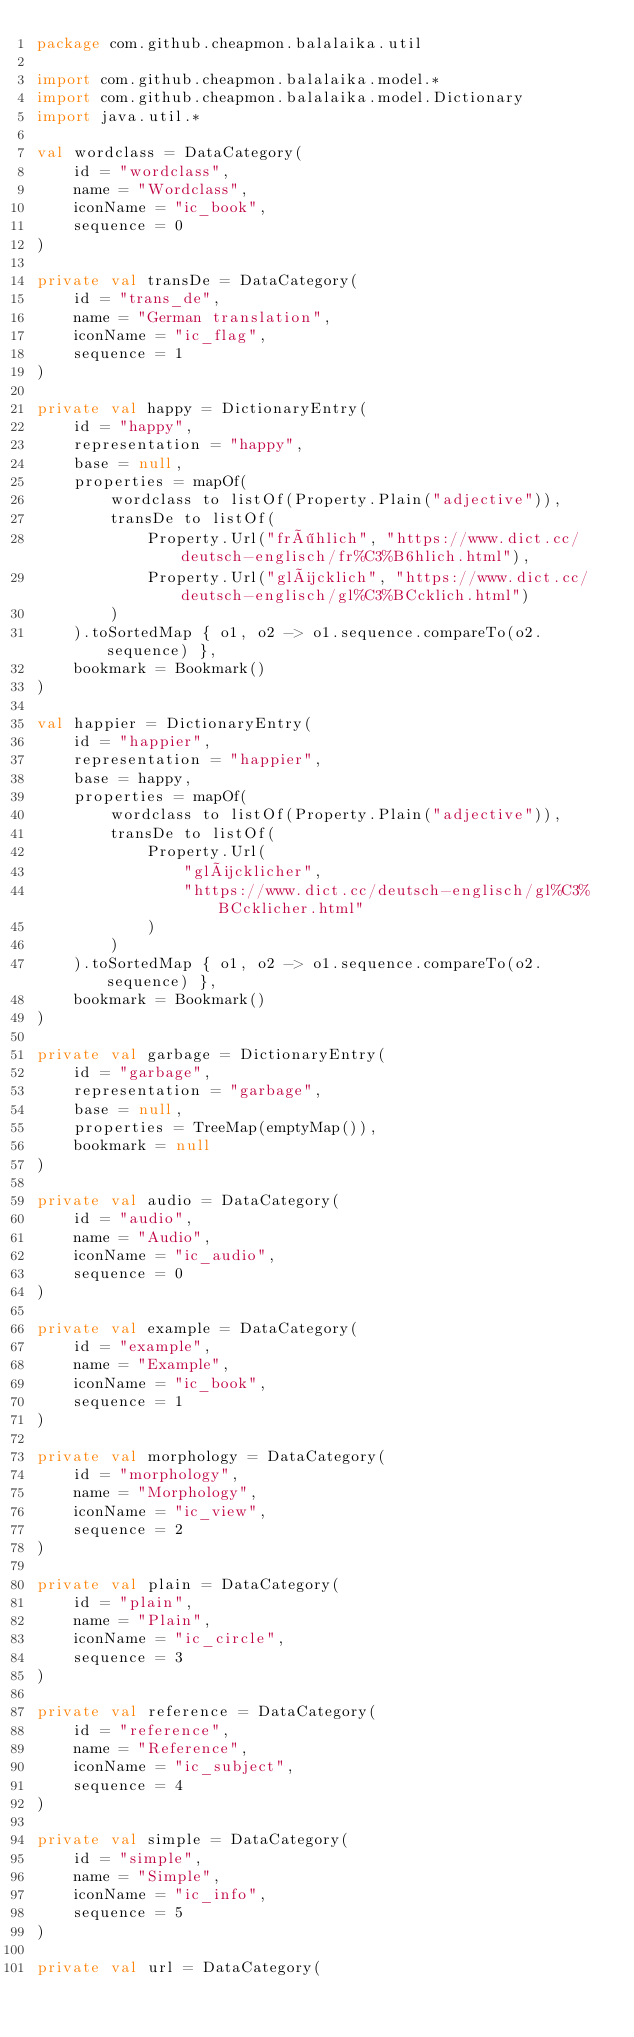<code> <loc_0><loc_0><loc_500><loc_500><_Kotlin_>package com.github.cheapmon.balalaika.util

import com.github.cheapmon.balalaika.model.*
import com.github.cheapmon.balalaika.model.Dictionary
import java.util.*

val wordclass = DataCategory(
    id = "wordclass",
    name = "Wordclass",
    iconName = "ic_book",
    sequence = 0
)

private val transDe = DataCategory(
    id = "trans_de",
    name = "German translation",
    iconName = "ic_flag",
    sequence = 1
)

private val happy = DictionaryEntry(
    id = "happy",
    representation = "happy",
    base = null,
    properties = mapOf(
        wordclass to listOf(Property.Plain("adjective")),
        transDe to listOf(
            Property.Url("fröhlich", "https://www.dict.cc/deutsch-englisch/fr%C3%B6hlich.html"),
            Property.Url("glücklich", "https://www.dict.cc/deutsch-englisch/gl%C3%BCcklich.html")
        )
    ).toSortedMap { o1, o2 -> o1.sequence.compareTo(o2.sequence) },
    bookmark = Bookmark()
)

val happier = DictionaryEntry(
    id = "happier",
    representation = "happier",
    base = happy,
    properties = mapOf(
        wordclass to listOf(Property.Plain("adjective")),
        transDe to listOf(
            Property.Url(
                "glücklicher",
                "https://www.dict.cc/deutsch-englisch/gl%C3%BCcklicher.html"
            )
        )
    ).toSortedMap { o1, o2 -> o1.sequence.compareTo(o2.sequence) },
    bookmark = Bookmark()
)

private val garbage = DictionaryEntry(
    id = "garbage",
    representation = "garbage",
    base = null,
    properties = TreeMap(emptyMap()),
    bookmark = null
)

private val audio = DataCategory(
    id = "audio",
    name = "Audio",
    iconName = "ic_audio",
    sequence = 0
)

private val example = DataCategory(
    id = "example",
    name = "Example",
    iconName = "ic_book",
    sequence = 1
)

private val morphology = DataCategory(
    id = "morphology",
    name = "Morphology",
    iconName = "ic_view",
    sequence = 2
)

private val plain = DataCategory(
    id = "plain",
    name = "Plain",
    iconName = "ic_circle",
    sequence = 3
)

private val reference = DataCategory(
    id = "reference",
    name = "Reference",
    iconName = "ic_subject",
    sequence = 4
)

private val simple = DataCategory(
    id = "simple",
    name = "Simple",
    iconName = "ic_info",
    sequence = 5
)

private val url = DataCategory(</code> 